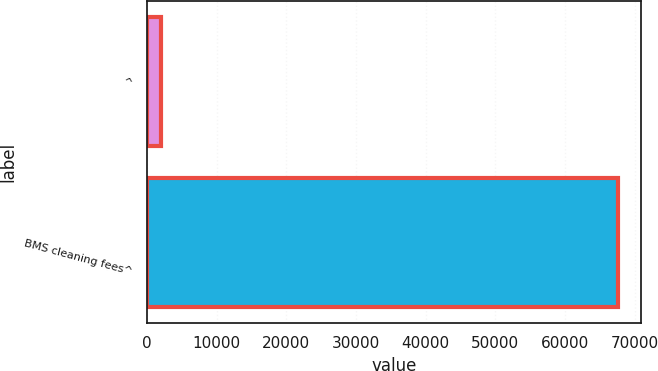Convert chart to OTSL. <chart><loc_0><loc_0><loc_500><loc_500><bar_chart><fcel>^<fcel>BMS cleaning fees^<nl><fcel>2012<fcel>67584<nl></chart> 